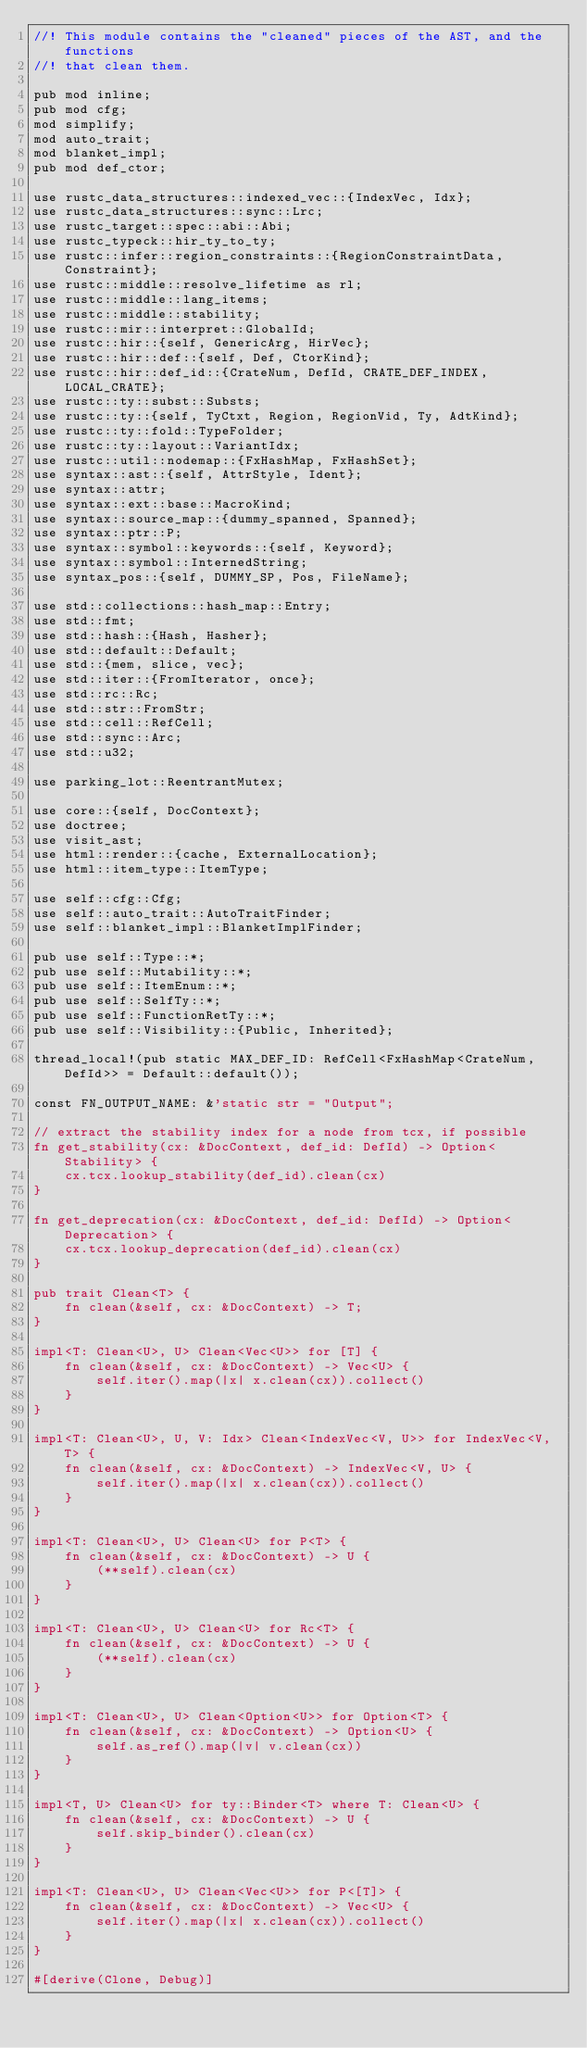<code> <loc_0><loc_0><loc_500><loc_500><_Rust_>//! This module contains the "cleaned" pieces of the AST, and the functions
//! that clean them.

pub mod inline;
pub mod cfg;
mod simplify;
mod auto_trait;
mod blanket_impl;
pub mod def_ctor;

use rustc_data_structures::indexed_vec::{IndexVec, Idx};
use rustc_data_structures::sync::Lrc;
use rustc_target::spec::abi::Abi;
use rustc_typeck::hir_ty_to_ty;
use rustc::infer::region_constraints::{RegionConstraintData, Constraint};
use rustc::middle::resolve_lifetime as rl;
use rustc::middle::lang_items;
use rustc::middle::stability;
use rustc::mir::interpret::GlobalId;
use rustc::hir::{self, GenericArg, HirVec};
use rustc::hir::def::{self, Def, CtorKind};
use rustc::hir::def_id::{CrateNum, DefId, CRATE_DEF_INDEX, LOCAL_CRATE};
use rustc::ty::subst::Substs;
use rustc::ty::{self, TyCtxt, Region, RegionVid, Ty, AdtKind};
use rustc::ty::fold::TypeFolder;
use rustc::ty::layout::VariantIdx;
use rustc::util::nodemap::{FxHashMap, FxHashSet};
use syntax::ast::{self, AttrStyle, Ident};
use syntax::attr;
use syntax::ext::base::MacroKind;
use syntax::source_map::{dummy_spanned, Spanned};
use syntax::ptr::P;
use syntax::symbol::keywords::{self, Keyword};
use syntax::symbol::InternedString;
use syntax_pos::{self, DUMMY_SP, Pos, FileName};

use std::collections::hash_map::Entry;
use std::fmt;
use std::hash::{Hash, Hasher};
use std::default::Default;
use std::{mem, slice, vec};
use std::iter::{FromIterator, once};
use std::rc::Rc;
use std::str::FromStr;
use std::cell::RefCell;
use std::sync::Arc;
use std::u32;

use parking_lot::ReentrantMutex;

use core::{self, DocContext};
use doctree;
use visit_ast;
use html::render::{cache, ExternalLocation};
use html::item_type::ItemType;

use self::cfg::Cfg;
use self::auto_trait::AutoTraitFinder;
use self::blanket_impl::BlanketImplFinder;

pub use self::Type::*;
pub use self::Mutability::*;
pub use self::ItemEnum::*;
pub use self::SelfTy::*;
pub use self::FunctionRetTy::*;
pub use self::Visibility::{Public, Inherited};

thread_local!(pub static MAX_DEF_ID: RefCell<FxHashMap<CrateNum, DefId>> = Default::default());

const FN_OUTPUT_NAME: &'static str = "Output";

// extract the stability index for a node from tcx, if possible
fn get_stability(cx: &DocContext, def_id: DefId) -> Option<Stability> {
    cx.tcx.lookup_stability(def_id).clean(cx)
}

fn get_deprecation(cx: &DocContext, def_id: DefId) -> Option<Deprecation> {
    cx.tcx.lookup_deprecation(def_id).clean(cx)
}

pub trait Clean<T> {
    fn clean(&self, cx: &DocContext) -> T;
}

impl<T: Clean<U>, U> Clean<Vec<U>> for [T] {
    fn clean(&self, cx: &DocContext) -> Vec<U> {
        self.iter().map(|x| x.clean(cx)).collect()
    }
}

impl<T: Clean<U>, U, V: Idx> Clean<IndexVec<V, U>> for IndexVec<V, T> {
    fn clean(&self, cx: &DocContext) -> IndexVec<V, U> {
        self.iter().map(|x| x.clean(cx)).collect()
    }
}

impl<T: Clean<U>, U> Clean<U> for P<T> {
    fn clean(&self, cx: &DocContext) -> U {
        (**self).clean(cx)
    }
}

impl<T: Clean<U>, U> Clean<U> for Rc<T> {
    fn clean(&self, cx: &DocContext) -> U {
        (**self).clean(cx)
    }
}

impl<T: Clean<U>, U> Clean<Option<U>> for Option<T> {
    fn clean(&self, cx: &DocContext) -> Option<U> {
        self.as_ref().map(|v| v.clean(cx))
    }
}

impl<T, U> Clean<U> for ty::Binder<T> where T: Clean<U> {
    fn clean(&self, cx: &DocContext) -> U {
        self.skip_binder().clean(cx)
    }
}

impl<T: Clean<U>, U> Clean<Vec<U>> for P<[T]> {
    fn clean(&self, cx: &DocContext) -> Vec<U> {
        self.iter().map(|x| x.clean(cx)).collect()
    }
}

#[derive(Clone, Debug)]</code> 